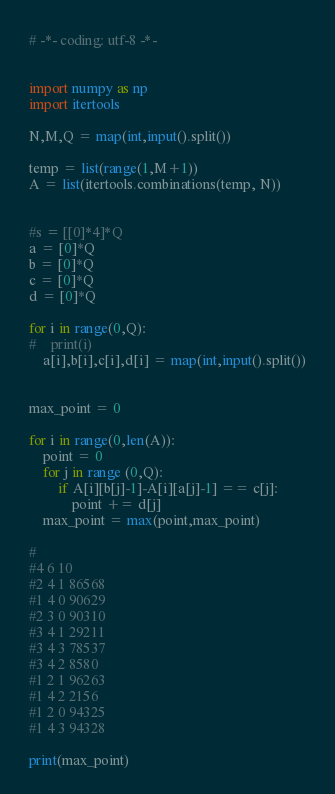<code> <loc_0><loc_0><loc_500><loc_500><_Python_># -*- coding: utf-8 -*-


import numpy as np
import itertools

N,M,Q = map(int,input().split())

temp = list(range(1,M+1))
A = list(itertools.combinations(temp, N))


#s = [[0]*4]*Q
a = [0]*Q
b = [0]*Q
c = [0]*Q
d = [0]*Q

for i in range(0,Q):
#    print(i)
    a[i],b[i],c[i],d[i] = map(int,input().split())
    

max_point = 0
    
for i in range(0,len(A)):
    point = 0
    for j in range (0,Q):
        if A[i][b[j]-1]-A[i][a[j]-1] == c[j]:
            point += d[j]
    max_point = max(point,max_point)
    
#
#4 6 10
#2 4 1 86568
#1 4 0 90629
#2 3 0 90310
#3 4 1 29211
#3 4 3 78537
#3 4 2 8580
#1 2 1 96263
#1 4 2 2156
#1 2 0 94325
#1 4 3 94328
        
print(max_point)</code> 